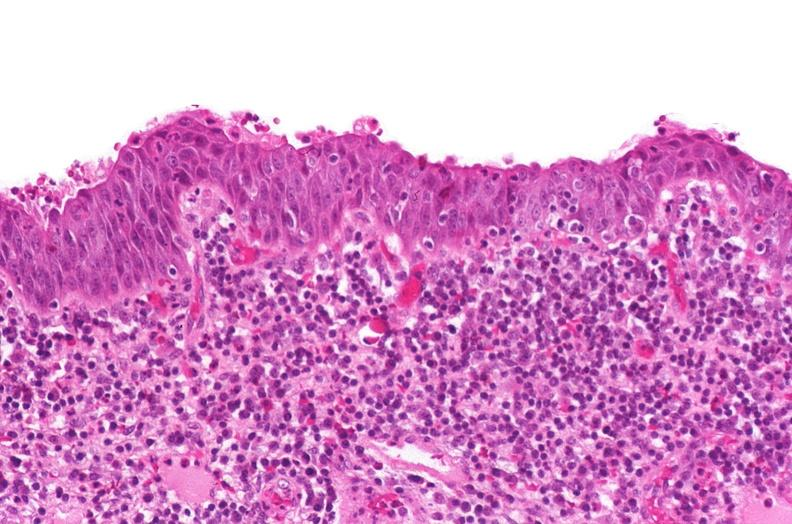does this image show renal pelvis, squamous metaplasia due to chronic urolithiasis?
Answer the question using a single word or phrase. Yes 